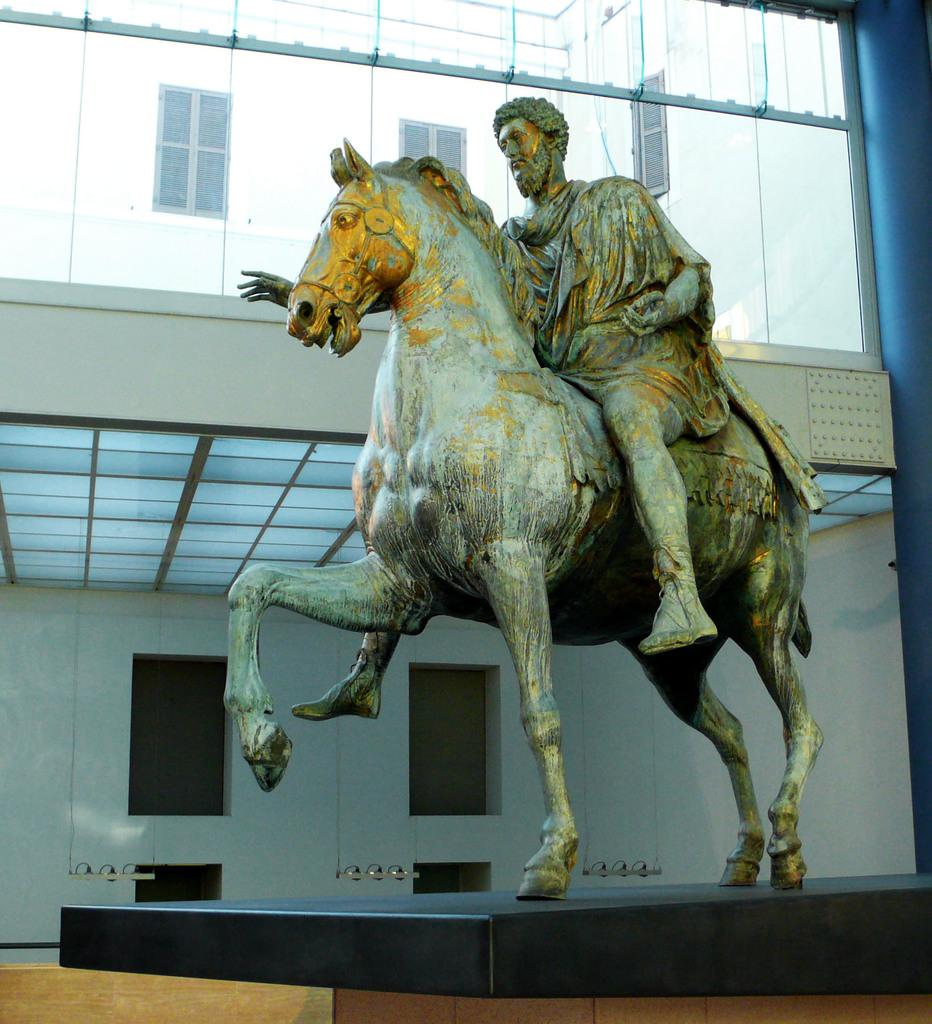What is the main subject in the middle of the image? There is a statue in the middle of the image. What can be seen in the background of the image? There is a building and glass visible in the background of the image. What type of meal is being served in the image? There is no meal present in the image; it features a statue and a background with a building and glass. 